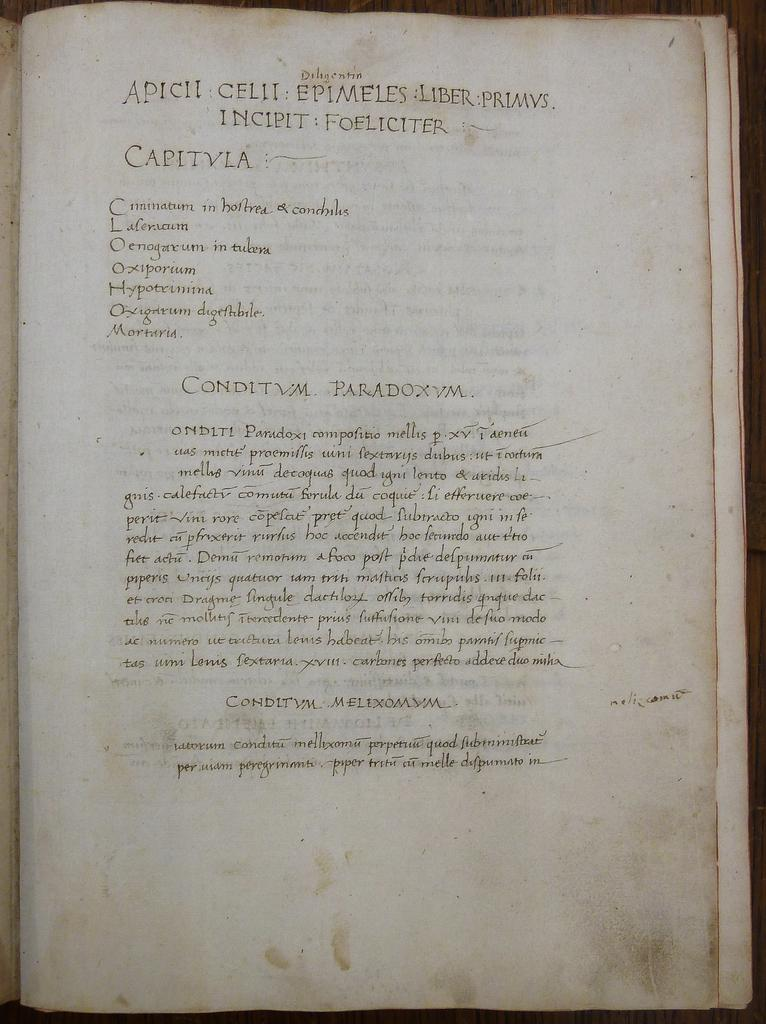Provide a one-sentence caption for the provided image. An old recipe book calls for ingredients such as Laleraum and Hypotrimina. 